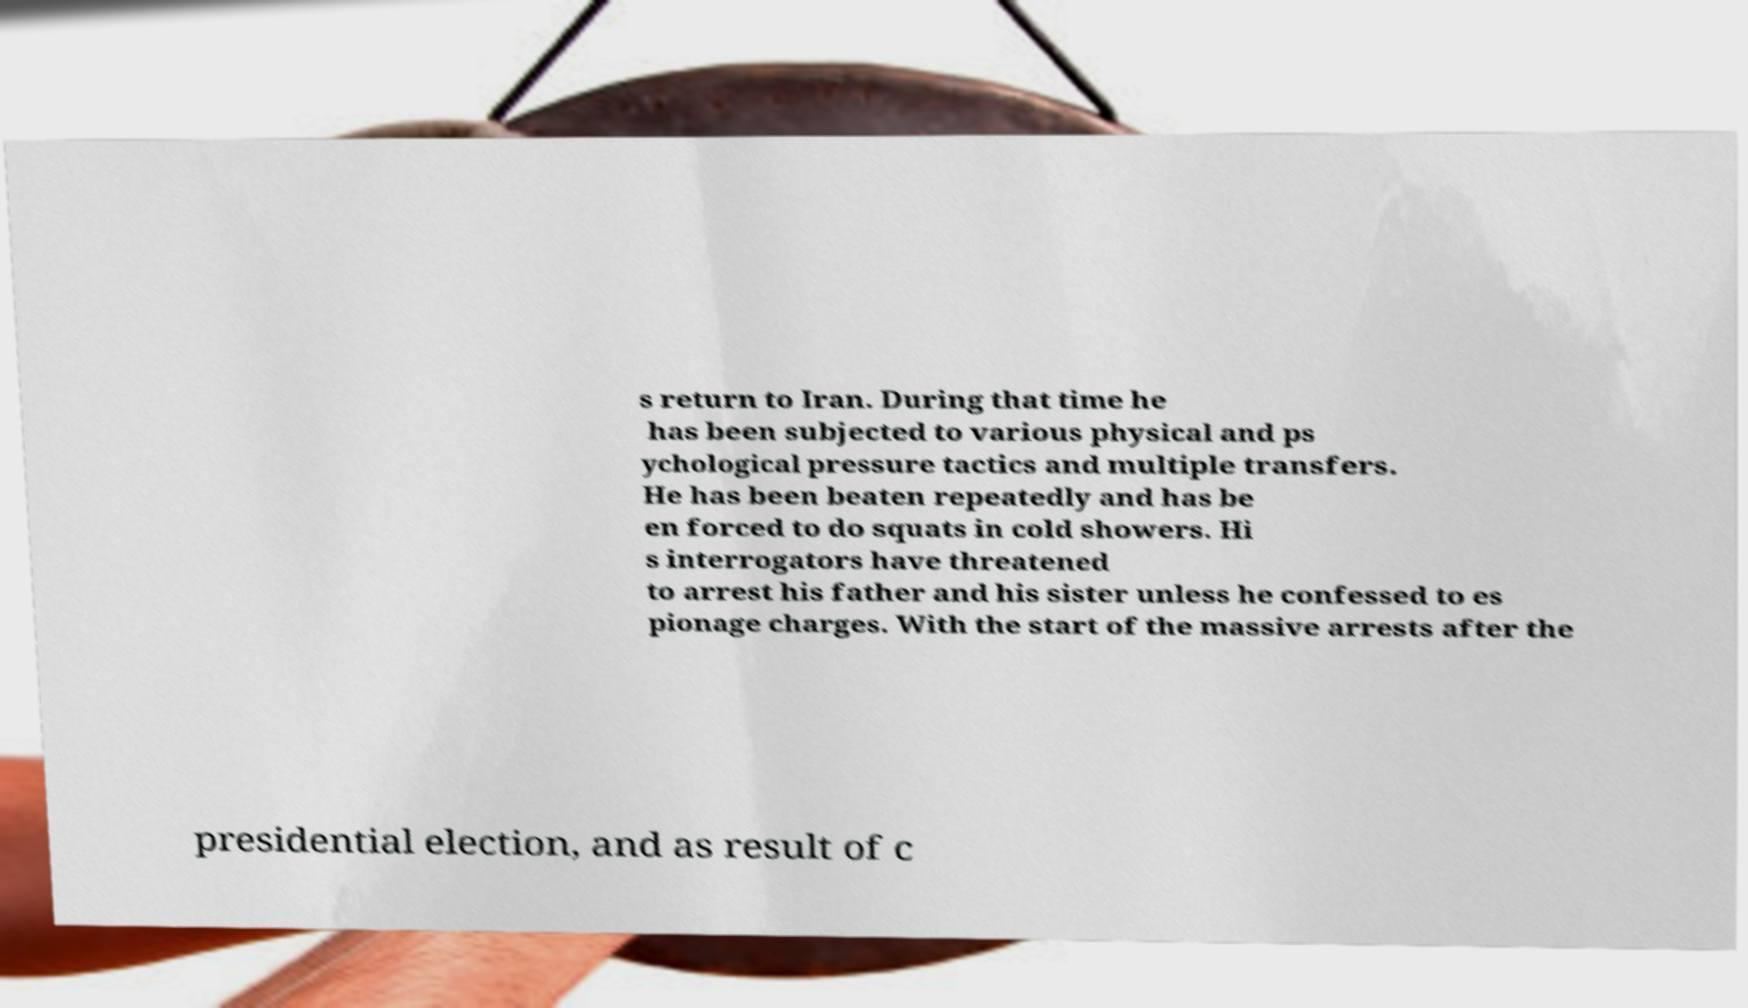Please read and relay the text visible in this image. What does it say? s return to Iran. During that time he has been subjected to various physical and ps ychological pressure tactics and multiple transfers. He has been beaten repeatedly and has be en forced to do squats in cold showers. Hi s interrogators have threatened to arrest his father and his sister unless he confessed to es pionage charges. With the start of the massive arrests after the presidential election, and as result of c 